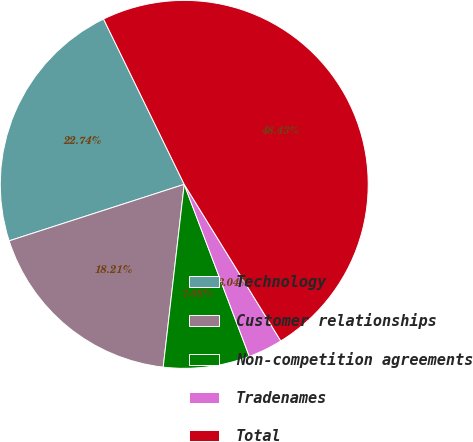<chart> <loc_0><loc_0><loc_500><loc_500><pie_chart><fcel>Technology<fcel>Customer relationships<fcel>Non-competition agreements<fcel>Tradenames<fcel>Total<nl><fcel>22.74%<fcel>18.21%<fcel>7.58%<fcel>3.04%<fcel>48.43%<nl></chart> 